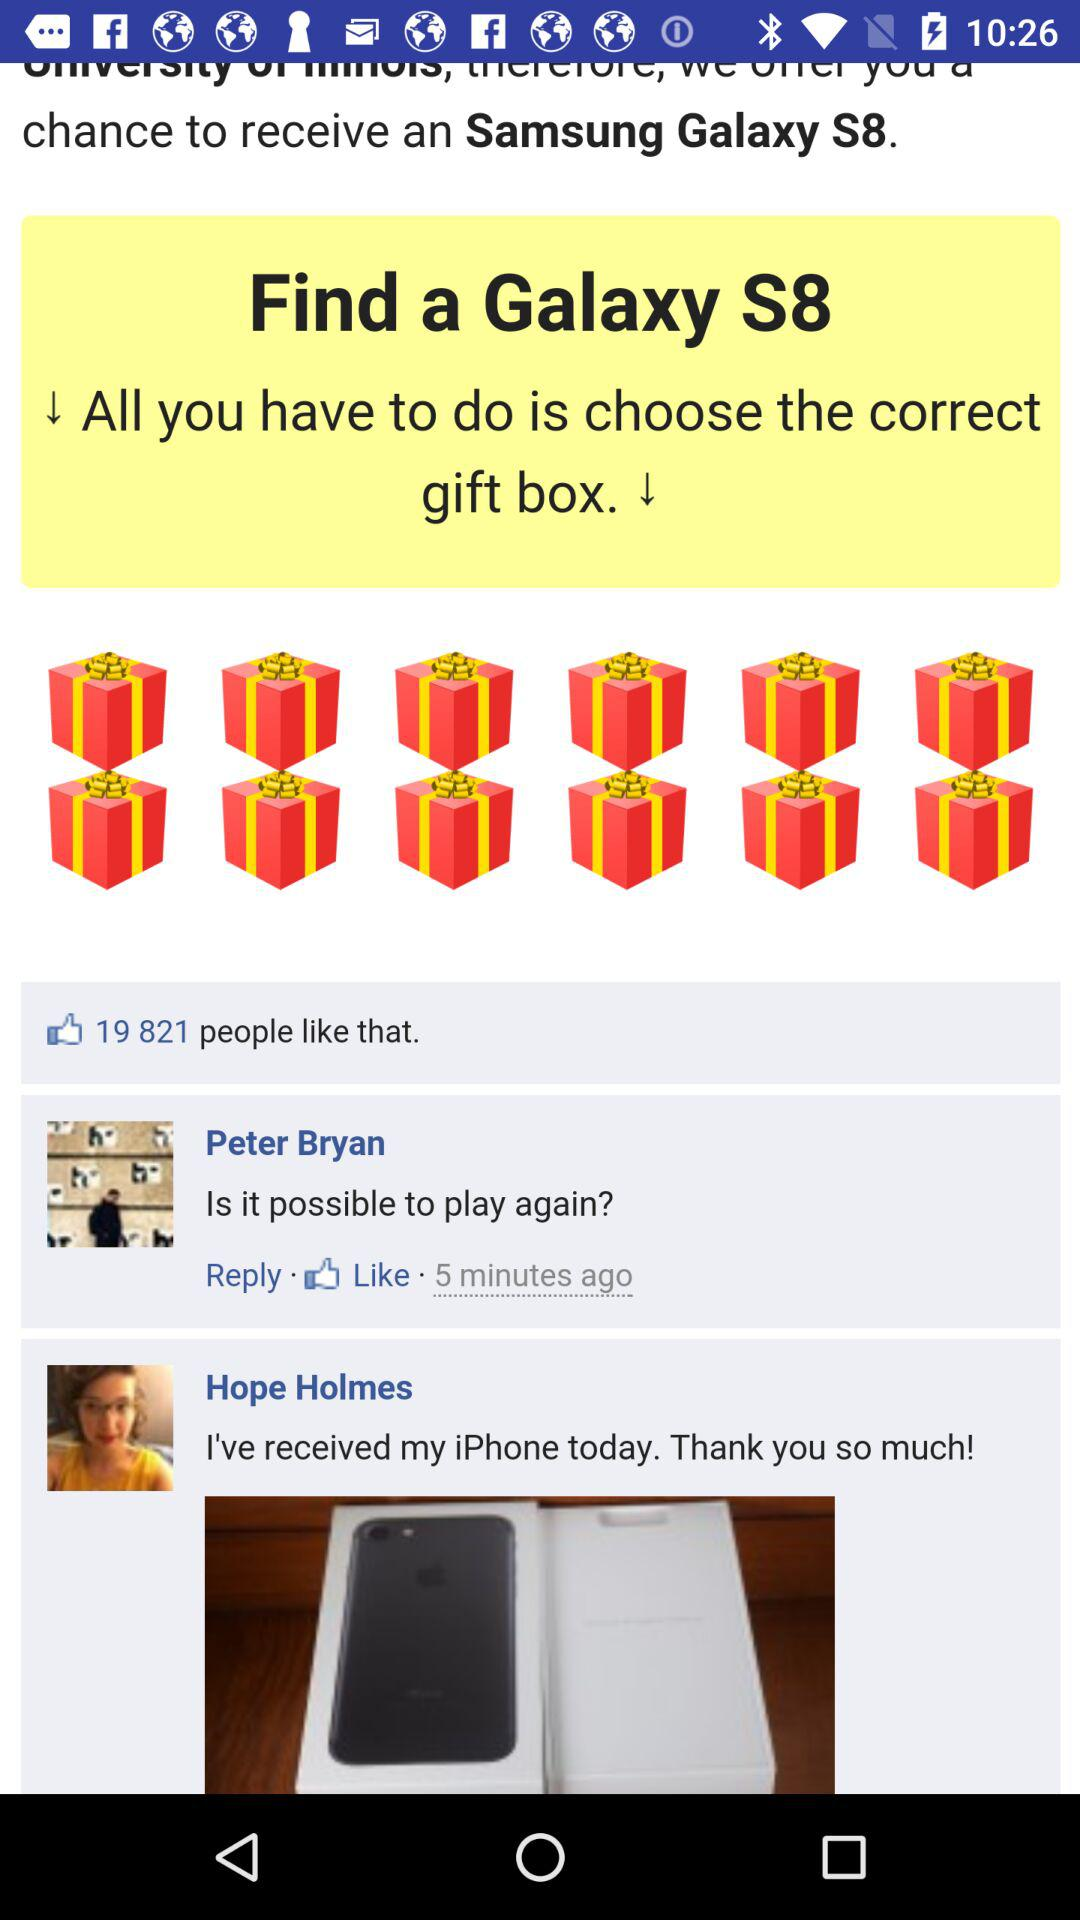When did Peter Bryan post the comment? Peter Bryan posted the comment 5 minutes ago. 